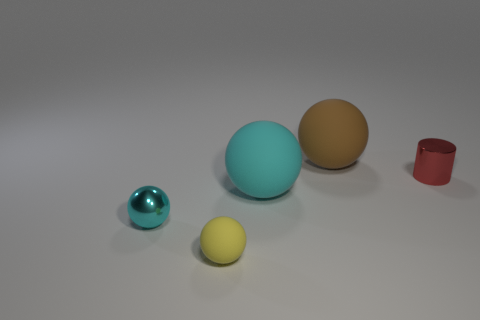How many things are either small shiny objects behind the big cyan rubber thing or small cyan metallic objects?
Offer a very short reply. 2. What shape is the metallic object that is right of the rubber ball on the left side of the large ball in front of the tiny cylinder?
Your answer should be very brief. Cylinder. How many other matte things are the same shape as the tiny yellow rubber object?
Offer a very short reply. 2. There is another sphere that is the same color as the shiny ball; what material is it?
Your response must be concise. Rubber. Are the brown sphere and the yellow thing made of the same material?
Make the answer very short. Yes. What number of large cyan balls are behind the large matte object behind the big rubber thing in front of the small red cylinder?
Provide a succinct answer. 0. Is there a big brown sphere made of the same material as the red object?
Your answer should be compact. No. What is the size of the matte sphere that is the same color as the tiny shiny ball?
Your response must be concise. Large. Is the number of small cylinders less than the number of cyan things?
Provide a succinct answer. Yes. Does the thing that is left of the yellow sphere have the same color as the shiny cylinder?
Your answer should be very brief. No. 